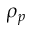Convert formula to latex. <formula><loc_0><loc_0><loc_500><loc_500>\rho _ { p }</formula> 